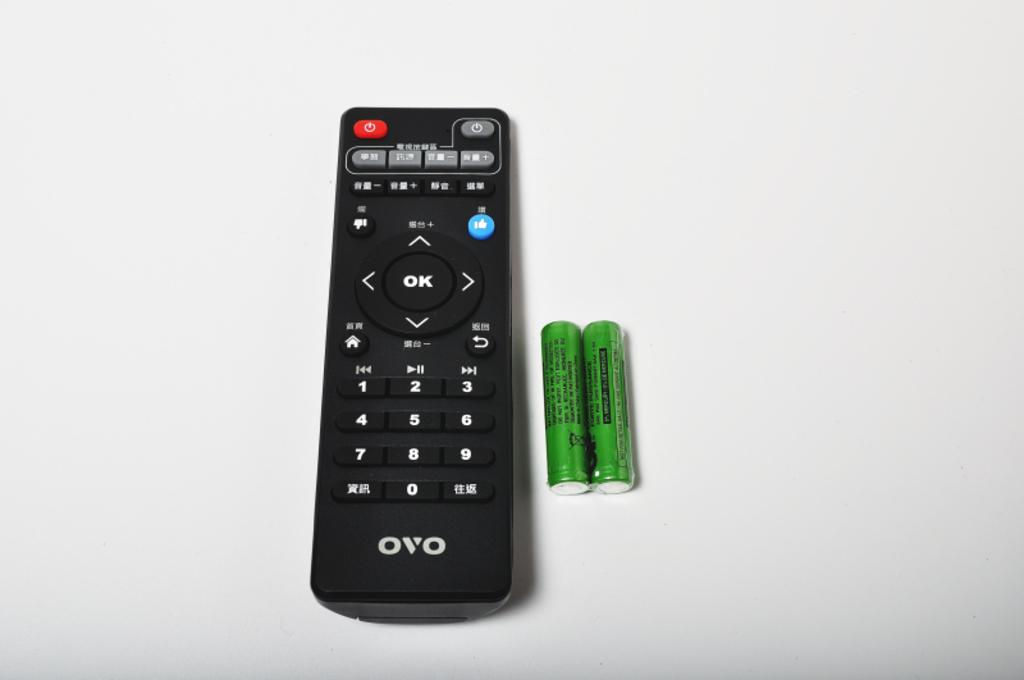<image>
Create a compact narrative representing the image presented. An OVO brand remote sits alongside two batteries. 